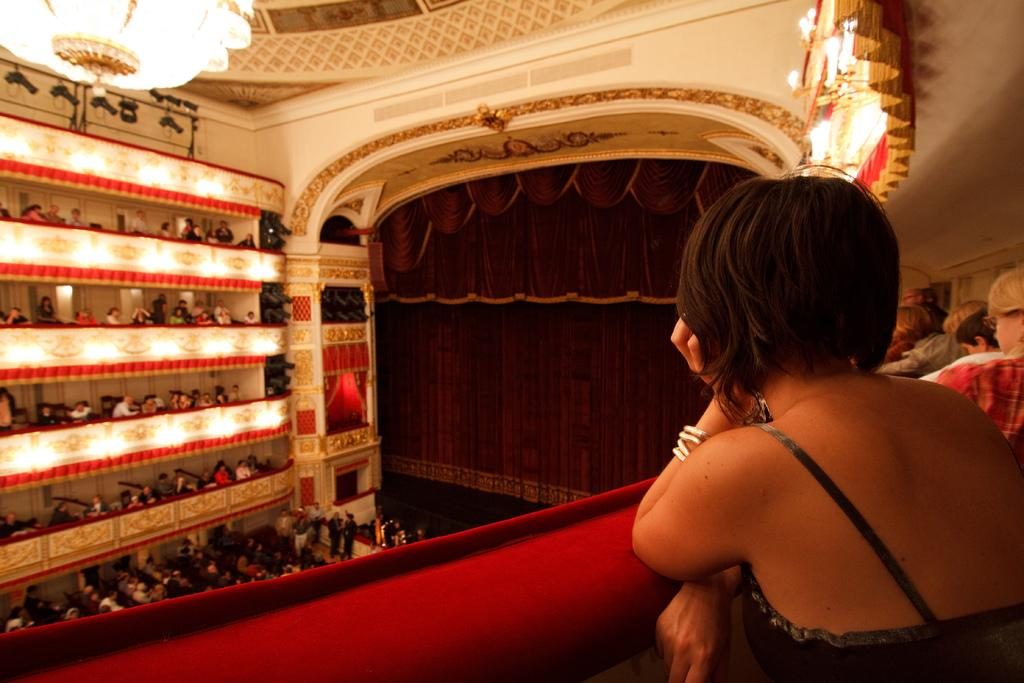How many people are in the group visible in the image? There is a group of persons in the image, but the exact number cannot be determined from the provided facts. What is in the background of the image? There is a curtain in the background of the image. What is hanging from the top in the image? The chandelier is hanging from the top in the image. What is the purpose of the lights on the chandelier? The lights on the chandelier provide illumination in the image. What time is displayed on the clock in the image? There is no clock present in the image; only a curtain, a group of persons, and a chandelier are visible. 